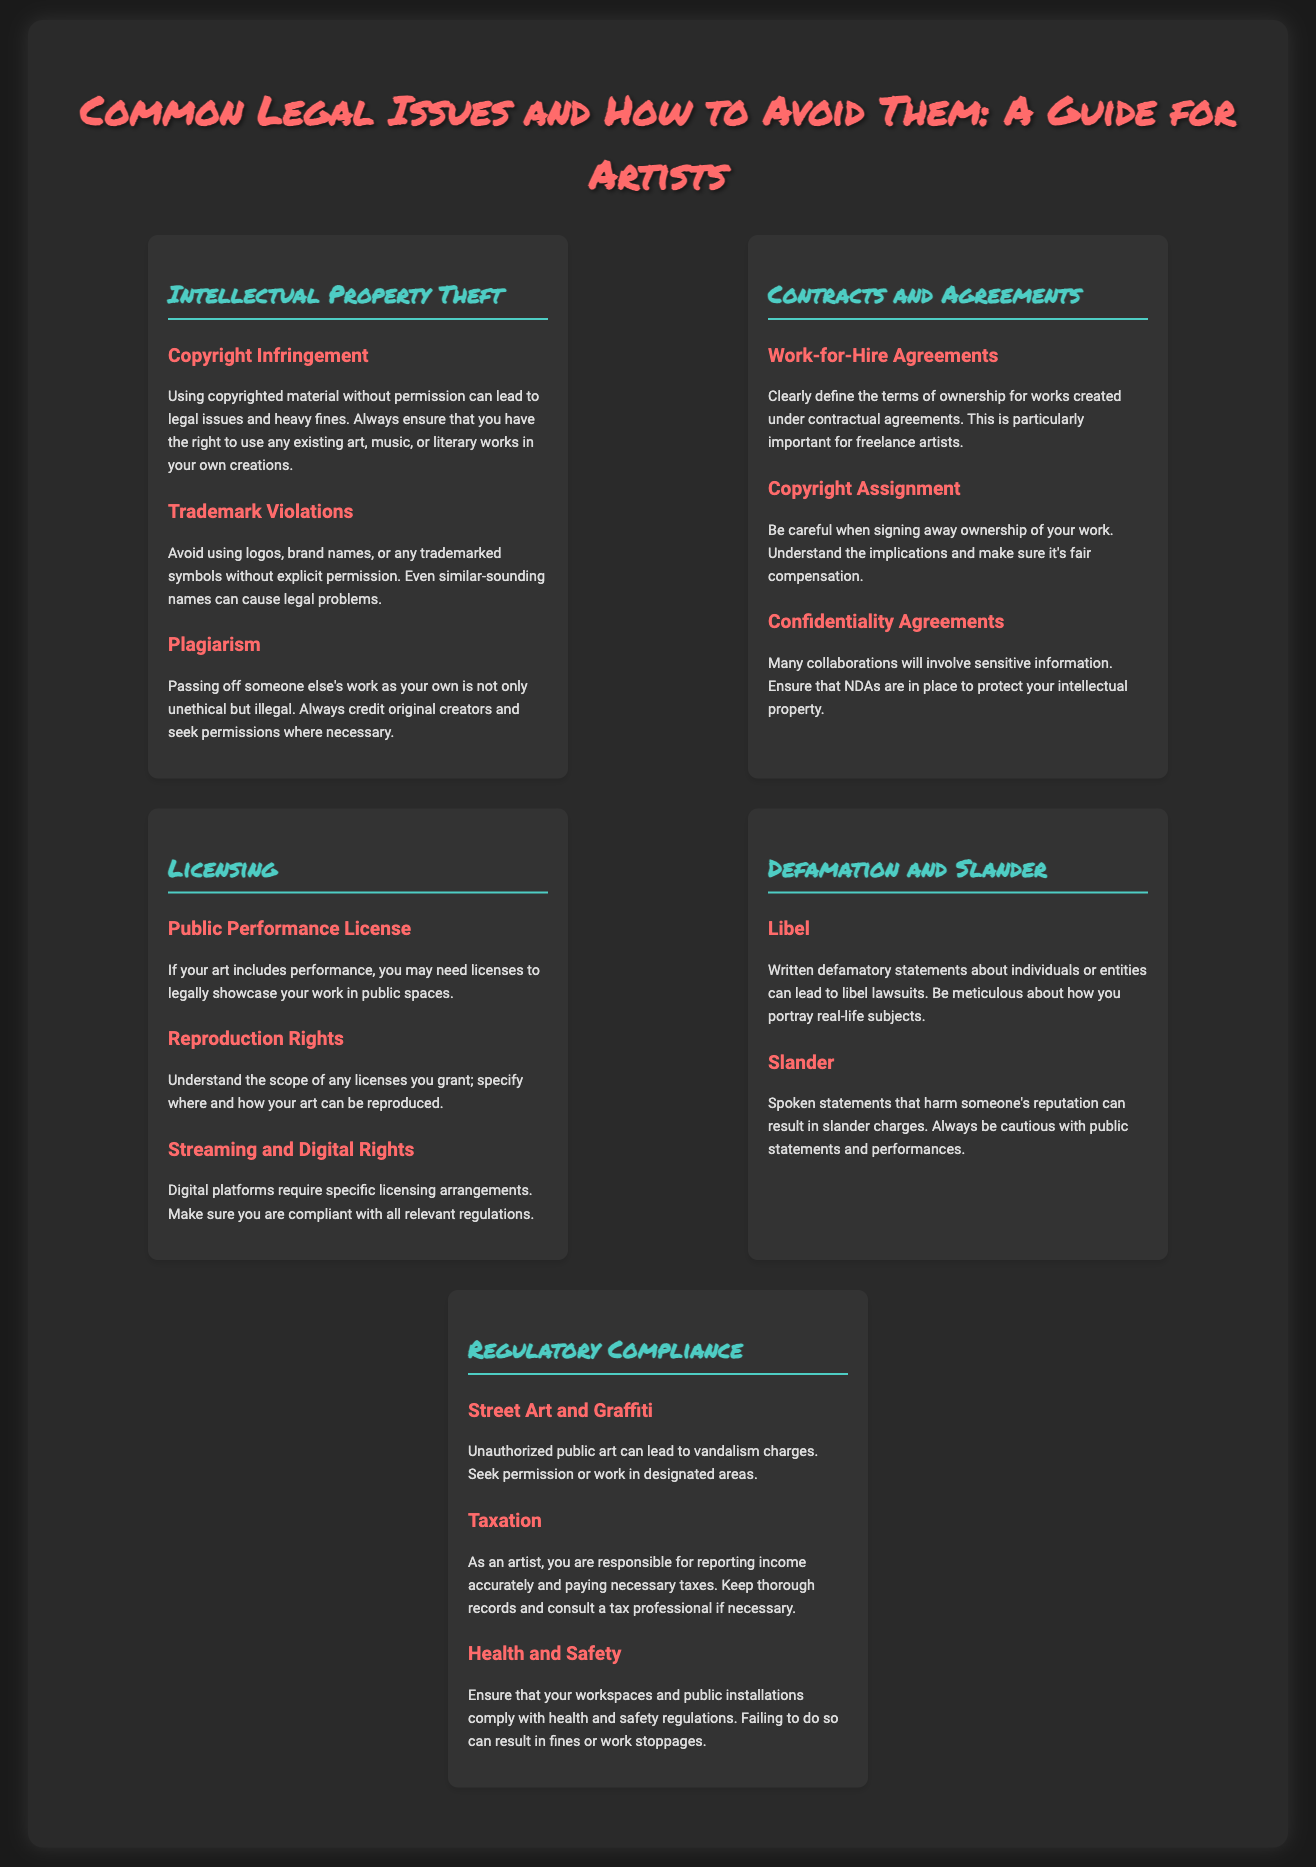What are the three main types of intellectual property issues listed? The document lists Copyright Infringement, Trademark Violations, and Plagiarism under Intellectual Property Theft.
Answer: Copyright Infringement, Trademark Violations, Plagiarism What does a Work-for-Hire Agreement define? It clearly defines the terms of ownership for works created under contractual agreements, particularly important for freelance artists.
Answer: Terms of ownership What type of license may be needed for public performances? The document mentions the need for a Public Performance License for showcasing work in public spaces.
Answer: Public Performance License What can written defamatory statements lead to? Written defamatory statements can lead to libel lawsuits as per the document.
Answer: Libel lawsuits What should artists ensure regarding their workspaces? Artists should ensure that their workspaces comply with health and safety regulations to avoid fines or work stoppages.
Answer: Compliance with health and safety regulations What is essential to avoid when using trademarks? The document emphasizes that using logos, brand names, or trademarked symbols without explicit permission can cause legal problems.
Answer: Explicit permission How many subsection topics are there under the "Licensing" section? The "Licensing" section has three subsections: Public Performance License, Reproduction Rights, and Streaming and Digital Rights.
Answer: Three What should artists keep thorough records of? The document highlights the importance of keeping thorough records regarding income and taxes for accurate reporting.
Answer: Income and taxes 